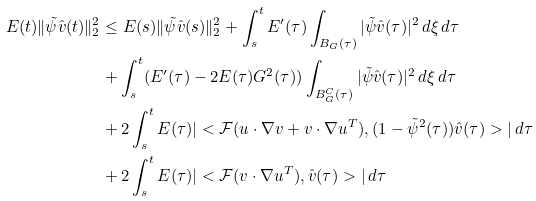<formula> <loc_0><loc_0><loc_500><loc_500>E ( t ) \| \tilde { \psi } \hat { v } ( t ) \| _ { 2 } ^ { 2 } & \leq E ( s ) \| \tilde { \psi } \hat { v } ( s ) \| _ { 2 } ^ { 2 } + \int _ { s } ^ { t } E ^ { \prime } ( \tau ) \int _ { B _ { G } ( \tau ) } | \tilde { \psi } \hat { v } ( \tau ) | ^ { 2 } \, d \xi \, d \tau \\ & + \int _ { s } ^ { t } ( E ^ { \prime } ( \tau ) - 2 E ( \tau ) G ^ { 2 } ( \tau ) ) \int _ { B _ { G } ^ { C } ( \tau ) } | \tilde { \psi } \hat { v } ( \tau ) | ^ { 2 } \, d \xi \, d \tau \\ & + 2 \int _ { s } ^ { t } E ( \tau ) | < \mathcal { F } ( u \cdot \nabla v + v \cdot \nabla u ^ { T } ) , ( 1 - \tilde { \psi } ^ { 2 } ( \tau ) ) \hat { v } ( \tau ) > | \, d \tau \\ & + 2 \int _ { s } ^ { t } E ( \tau ) | < \mathcal { F } ( v \cdot \nabla u ^ { T } ) , \hat { v } ( \tau ) > | \, d \tau</formula> 